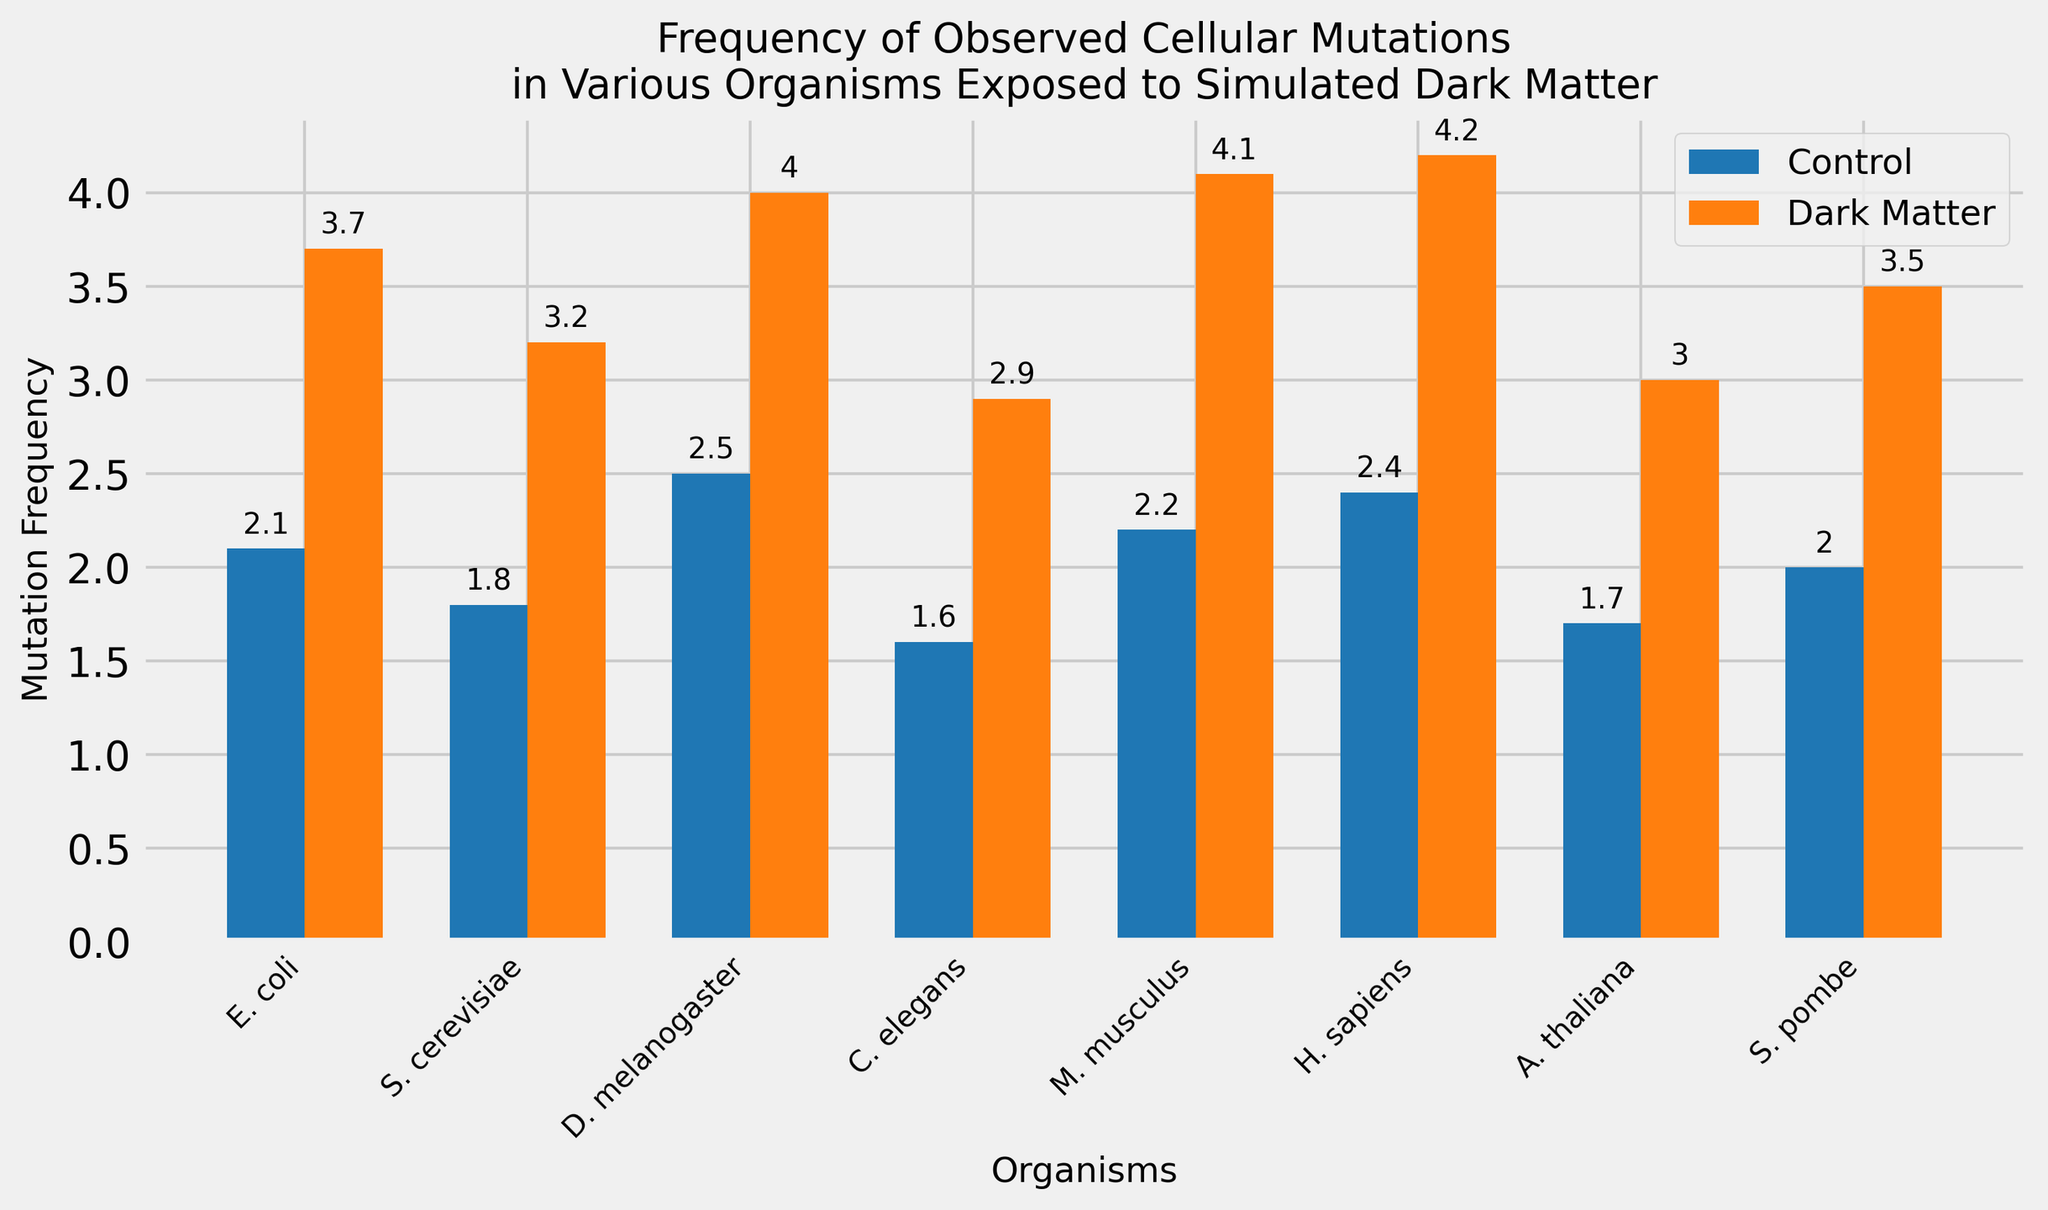Which organism shows the highest mutation frequency under simulated dark matter exposure? Look at the bar heights for the "Dark Matter" category and identify the tallest. H. sapiens has the tallest bar under dark matter exposure.
Answer: H. sapiens How much higher is the mutation frequency for C. elegans under dark matter exposure compared to the control? Subtract the control mutation frequency of C. elegans from its dark matter mutation frequency: 2.9 - 1.6 = 1.3
Answer: 1.3 Which organism has the smallest difference between control and dark matter mutation frequencies? Calculate the differences for each organism and identify the smallest difference. S. cerevisiae shows the smallest difference: 3.2 - 1.8 = 1.4
Answer: S. cerevisiae What is the average mutation frequency for the organisms under the dark matter condition? Sum up the dark matter mutation frequencies and divide by the number of organisms: (3.7 + 3.2 + 4.0 + 2.9 + 4.1 + 4.2 + 3.0 + 3.5)/8 = 3.575
Answer: 3.575 For which organisms is the difference between control and dark matter mutation frequencies greater than 1.5? Calculate the difference for each organism: E. coli (1.6), S. cerevisiae (1.4), D. melanogaster (1.5), C. elegans (1.3), M. musculus (1.9), H. sapiens (1.8), A. thaliana (1.3), S. pombe (1.5). The qualifying organisms are D. melanogaster, M. musculus, H. sapiens, and S. pombe
Answer: D. melanogaster, M. musculus, H. sapiens, S. pombe What is the combined mutation frequency for all organisms under control conditions? Sum up all control mutation frequencies: 2.1 + 1.8 + 2.5 + 1.6 + 2.2 + 2.4 + 1.7 + 2.0 = 16.3
Answer: 16.3 Which organism shows the greatest relative increase in mutation frequency under dark matter exposure? Calculate the relative increase as (dark matter frequency - control frequency) / control frequency for each organism. The largest relative increase is found by comparing all calculated values: H. sapiens shows the greatest relative increase (4.2 - 2.4) / 2.4 ≈ 0.75
Answer: H. sapiens Which two organisms have the same difference between control and dark matter mutation frequencies? Calculate the differences: E. coli (1.6), S. cerevisiae (1.4), D. melanogaster (1.5), C. elegans (1.3), M. musculus (1.9), H. sapiens (1.8), A. thaliana (1.3), S. pombe (1.5). D. melanogaster and S. pombe both have a difference of 1.5
Answer: D. melanogaster, S. pombe Which bar representing the control condition is the shortest? Identify the shortest bar among the control frequencies. The shortest control bar belongs to C. elegans with a mutation frequency of 1.6
Answer: C. elegans 